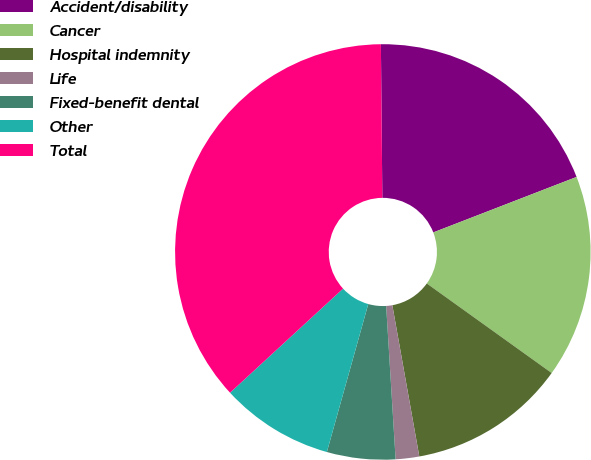<chart> <loc_0><loc_0><loc_500><loc_500><pie_chart><fcel>Accident/disability<fcel>Cancer<fcel>Hospital indemnity<fcel>Life<fcel>Fixed-benefit dental<fcel>Other<fcel>Total<nl><fcel>19.27%<fcel>15.78%<fcel>12.29%<fcel>1.83%<fcel>5.32%<fcel>8.81%<fcel>36.7%<nl></chart> 